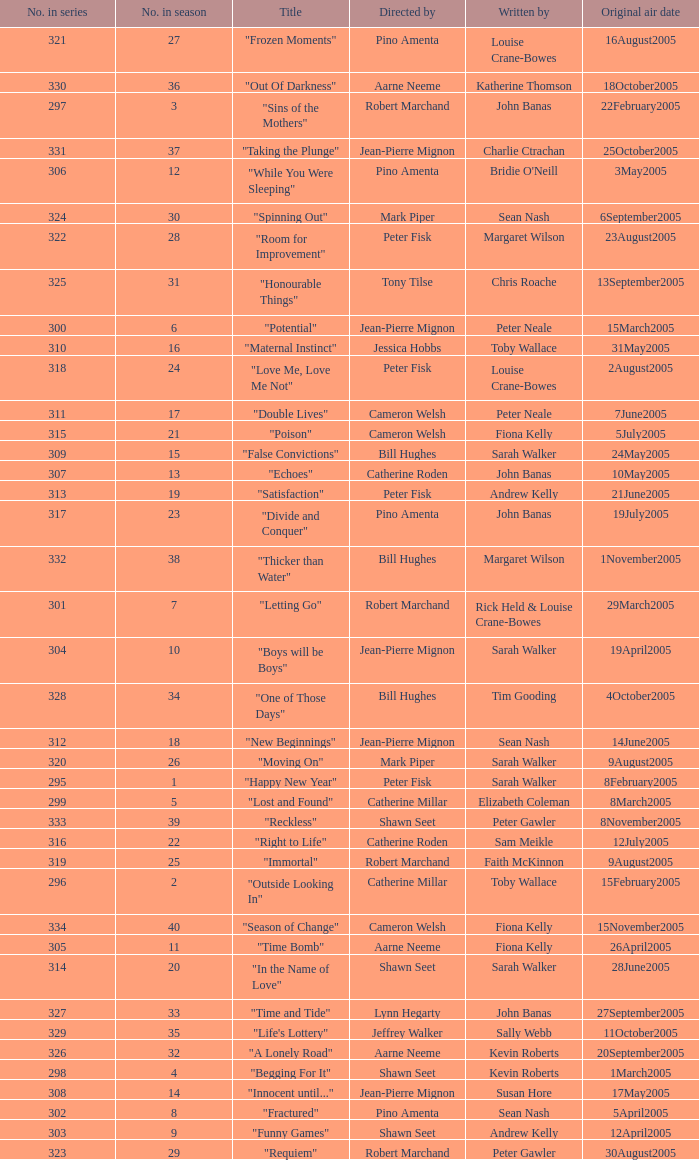Name the total number in the series written by john banas and directed by pino amenta 1.0. 